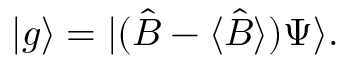<formula> <loc_0><loc_0><loc_500><loc_500>| g \rangle = | ( { \hat { B } } - \langle { \hat { B } } \rangle ) \Psi \rangle .</formula> 